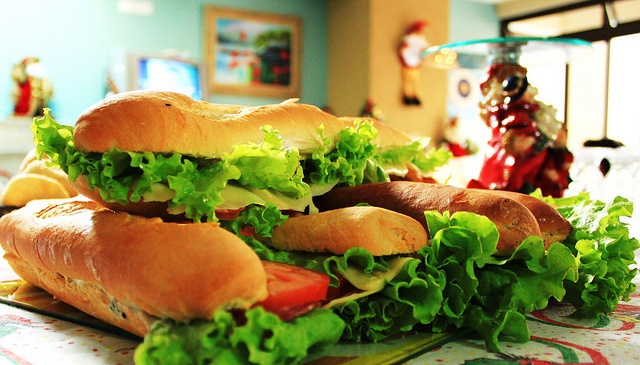Describe the objects in this image and their specific colors. I can see sandwich in white, green, orange, khaki, and olive tones, sandwich in white, red, and orange tones, sandwich in white, black, darkgreen, orange, and brown tones, sandwich in white, brown, black, maroon, and tan tones, and sandwich in white, maroon, brown, and orange tones in this image. 